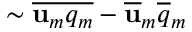Convert formula to latex. <formula><loc_0><loc_0><loc_500><loc_500>\sim \overline { { u _ { m } q _ { m } } } - \overline { u } _ { m } \overline { q } _ { m }</formula> 